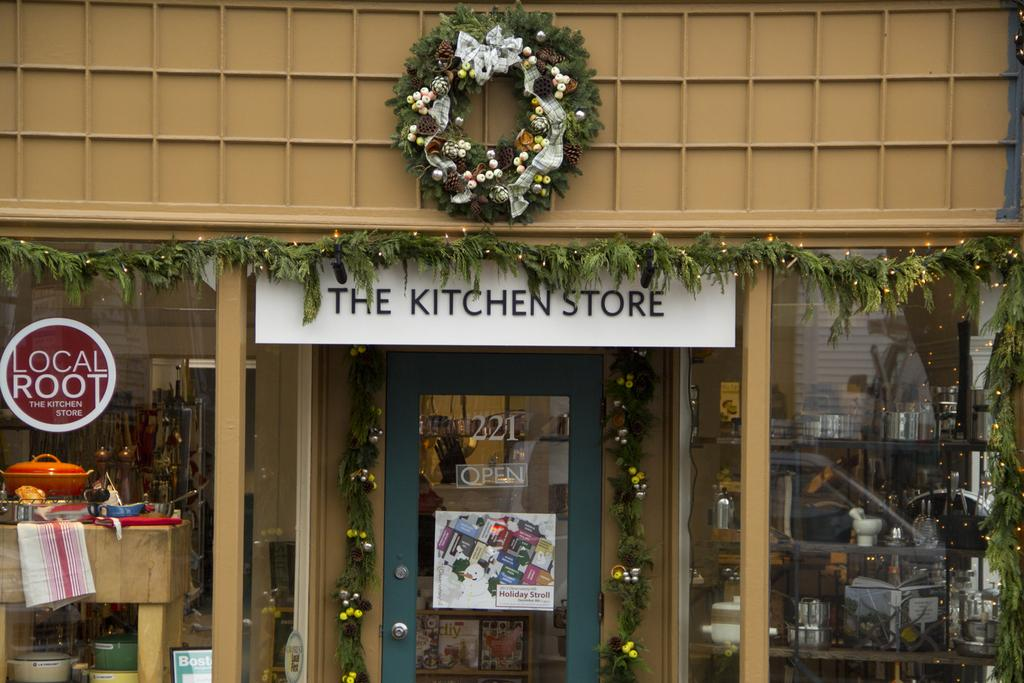Provide a one-sentence caption for the provided image. A store front called the kitchen store is covered in wreaths and other Christmas decorations. 